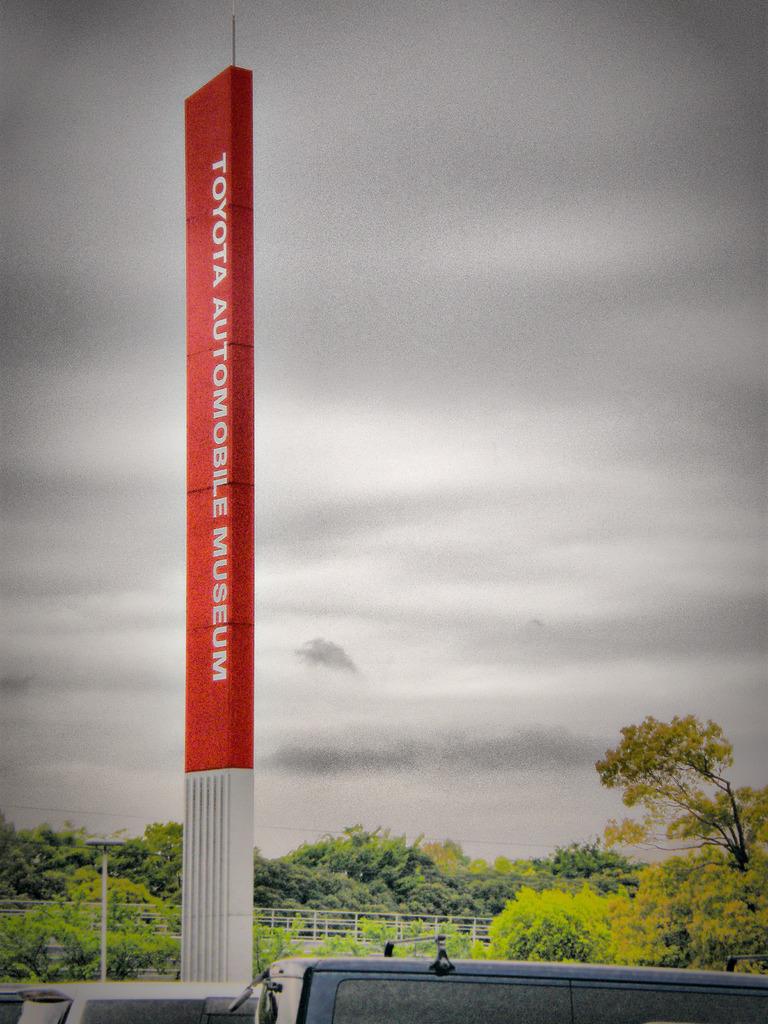Which attraction is the red sign advertising?
Provide a short and direct response. Toyota automobile museum. What is the car brand?
Offer a very short reply. Toyota. 